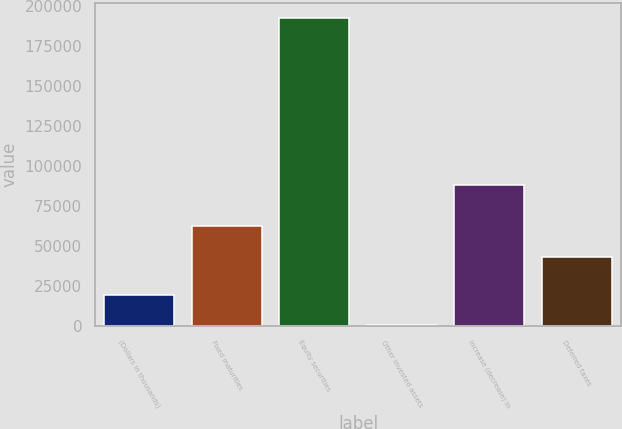Convert chart to OTSL. <chart><loc_0><loc_0><loc_500><loc_500><bar_chart><fcel>(Dollars in thousands)<fcel>Fixed maturities<fcel>Equity securities<fcel>Other invested assets<fcel>Increase (decrease) in<fcel>Deferred taxes<nl><fcel>19654.2<fcel>62587.2<fcel>192348<fcel>466<fcel>88273<fcel>43399<nl></chart> 